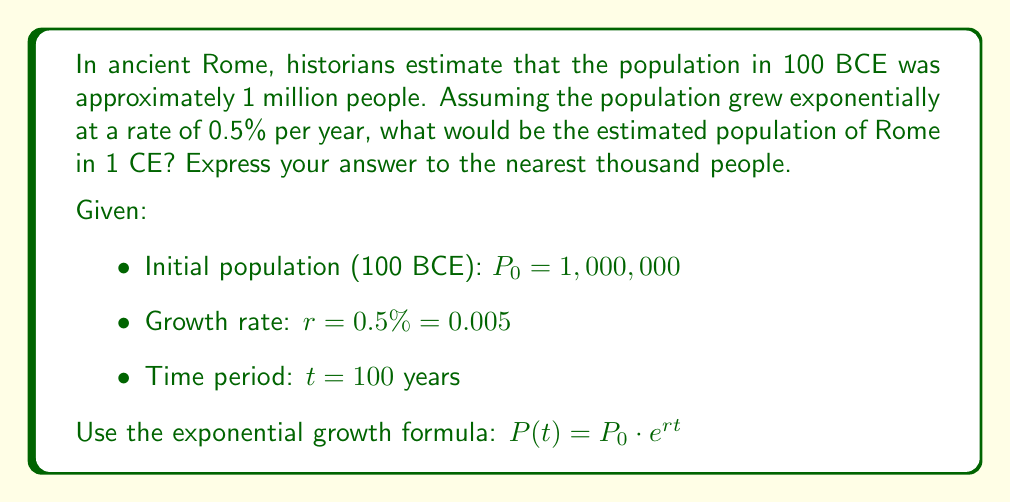Show me your answer to this math problem. To solve this problem, we'll use the exponential growth formula and follow these steps:

1. Identify the given information:
   $P_0 = 1,000,000$ (initial population)
   $r = 0.005$ (growth rate as a decimal)
   $t = 100$ years

2. Plug the values into the exponential growth formula:
   $P(t) = P_0 \cdot e^{rt}$
   $P(100) = 1,000,000 \cdot e^{0.005 \cdot 100}$

3. Simplify the exponent:
   $P(100) = 1,000,000 \cdot e^{0.5}$

4. Calculate the value of $e^{0.5}$:
   $e^{0.5} \approx 1.6487$

5. Multiply:
   $P(100) = 1,000,000 \cdot 1.6487 \approx 1,648,700$

6. Round to the nearest thousand:
   $P(100) \approx 1,649,000$

Therefore, the estimated population of Rome in 1 CE would be approximately 1,649,000 people.
Answer: 1,649,000 people 